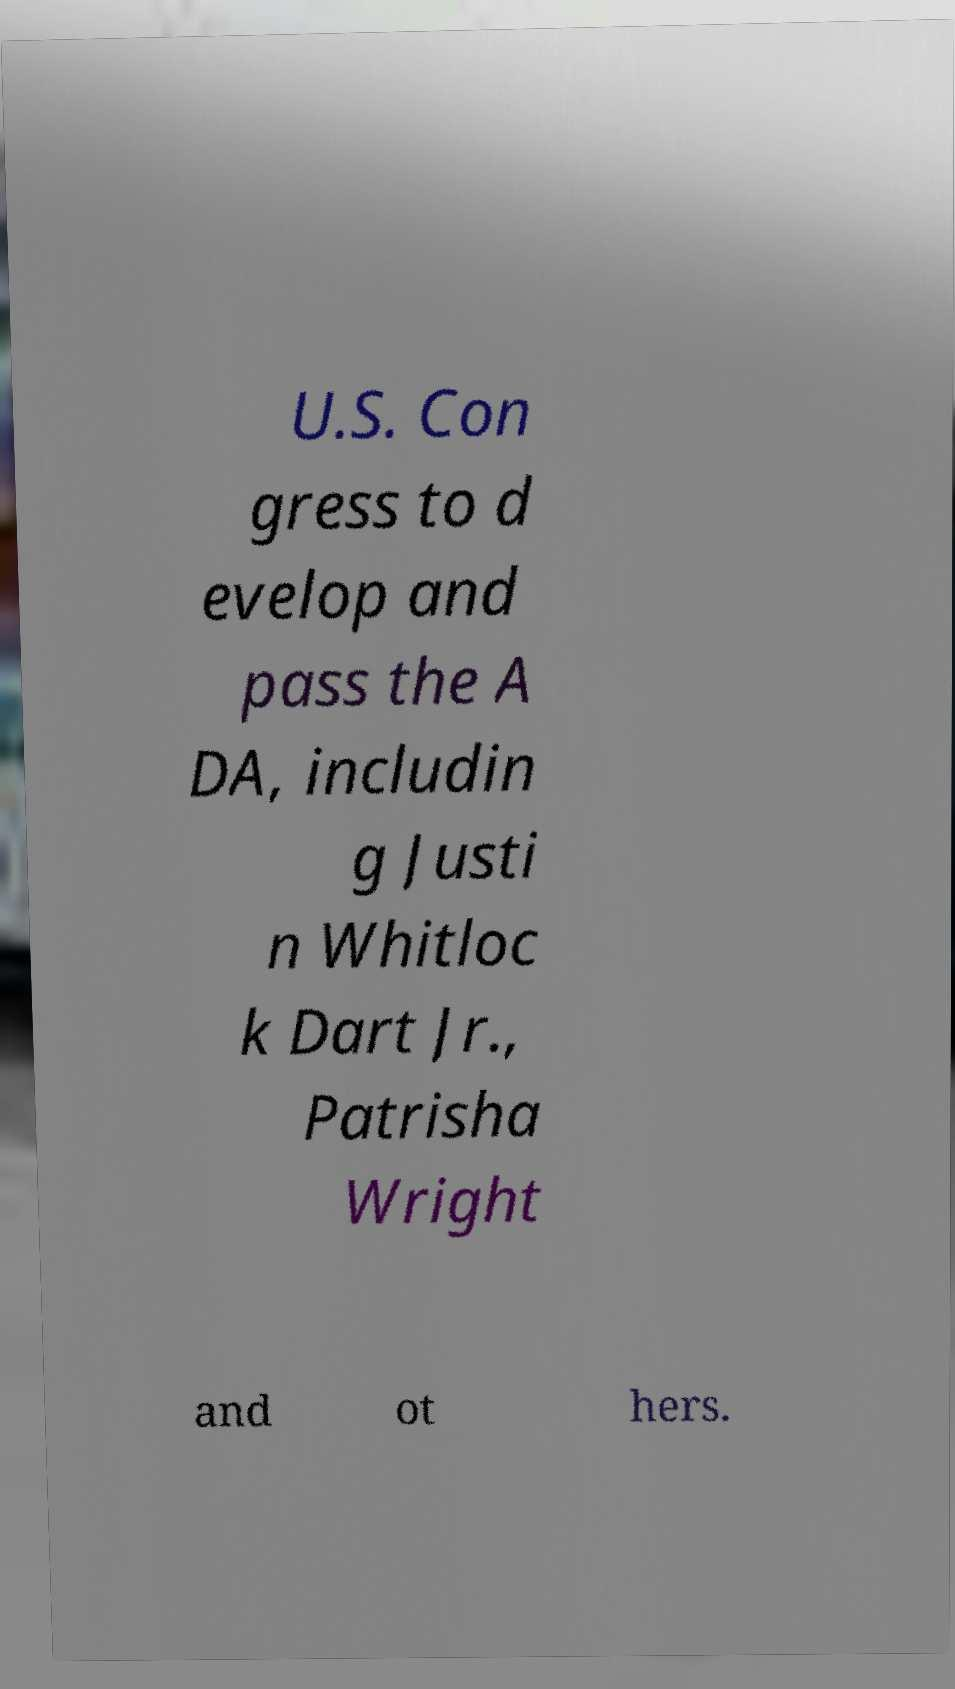What messages or text are displayed in this image? I need them in a readable, typed format. U.S. Con gress to d evelop and pass the A DA, includin g Justi n Whitloc k Dart Jr., Patrisha Wright and ot hers. 